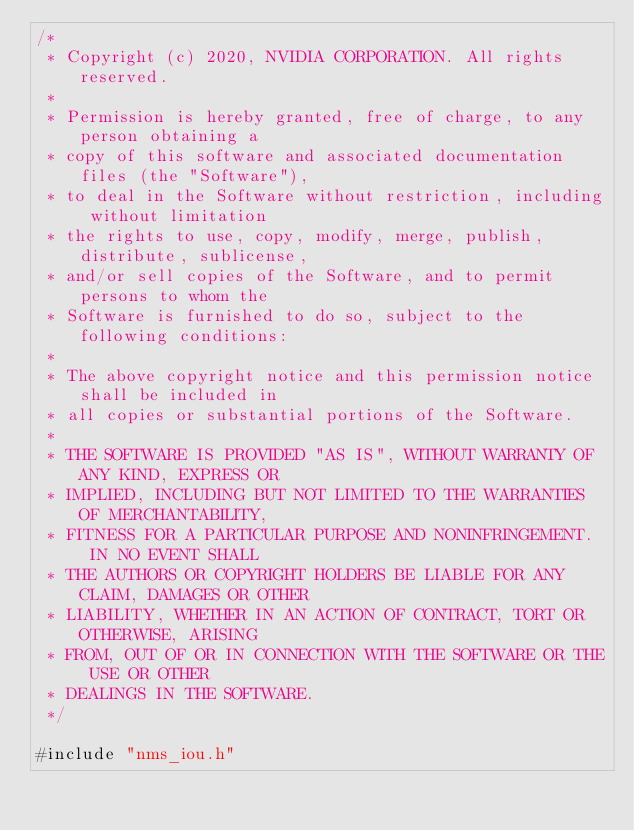<code> <loc_0><loc_0><loc_500><loc_500><_Cuda_>/*
 * Copyright (c) 2020, NVIDIA CORPORATION. All rights reserved.
 *
 * Permission is hereby granted, free of charge, to any person obtaining a
 * copy of this software and associated documentation files (the "Software"),
 * to deal in the Software without restriction, including without limitation
 * the rights to use, copy, modify, merge, publish, distribute, sublicense,
 * and/or sell copies of the Software, and to permit persons to whom the
 * Software is furnished to do so, subject to the following conditions:
 *
 * The above copyright notice and this permission notice shall be included in
 * all copies or substantial portions of the Software.
 *
 * THE SOFTWARE IS PROVIDED "AS IS", WITHOUT WARRANTY OF ANY KIND, EXPRESS OR
 * IMPLIED, INCLUDING BUT NOT LIMITED TO THE WARRANTIES OF MERCHANTABILITY,
 * FITNESS FOR A PARTICULAR PURPOSE AND NONINFRINGEMENT.  IN NO EVENT SHALL
 * THE AUTHORS OR COPYRIGHT HOLDERS BE LIABLE FOR ANY CLAIM, DAMAGES OR OTHER
 * LIABILITY, WHETHER IN AN ACTION OF CONTRACT, TORT OR OTHERWISE, ARISING
 * FROM, OUT OF OR IN CONNECTION WITH THE SOFTWARE OR THE USE OR OTHER
 * DEALINGS IN THE SOFTWARE.
 */

#include "nms_iou.h"</code> 